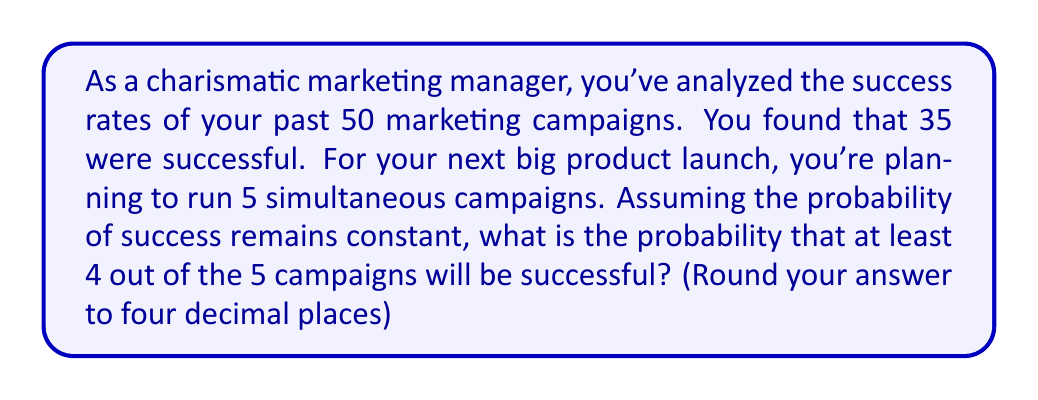Can you answer this question? Let's approach this step-by-step:

1) First, we need to calculate the probability of a single campaign being successful based on historical data:

   $p = \frac{\text{number of successful campaigns}}{\text{total number of campaigns}} = \frac{35}{50} = 0.7$

2) Now, we're looking at a binomial probability problem. We want the probability of at least 4 successes out of 5 trials. This can be calculated as the probability of exactly 4 successes plus the probability of 5 successes.

3) The probability mass function for a binomial distribution is:

   $P(X=k) = \binom{n}{k} p^k (1-p)^{n-k}$

   where $n$ is the number of trials, $k$ is the number of successes, and $p$ is the probability of success on each trial.

4) For 4 successes out of 5:

   $P(X=4) = \binom{5}{4} (0.7)^4 (0.3)^1 = 5 \cdot 0.2401 \cdot 0.3 = 0.36015$

5) For 5 successes out of 5:

   $P(X=5) = \binom{5}{5} (0.7)^5 (0.3)^0 = 1 \cdot 0.16807 \cdot 1 = 0.16807$

6) The probability of at least 4 successes is the sum of these probabilities:

   $P(X \geq 4) = P(X=4) + P(X=5) = 0.36015 + 0.16807 = 0.52822$

7) Rounding to four decimal places: 0.5282
Answer: 0.5282 